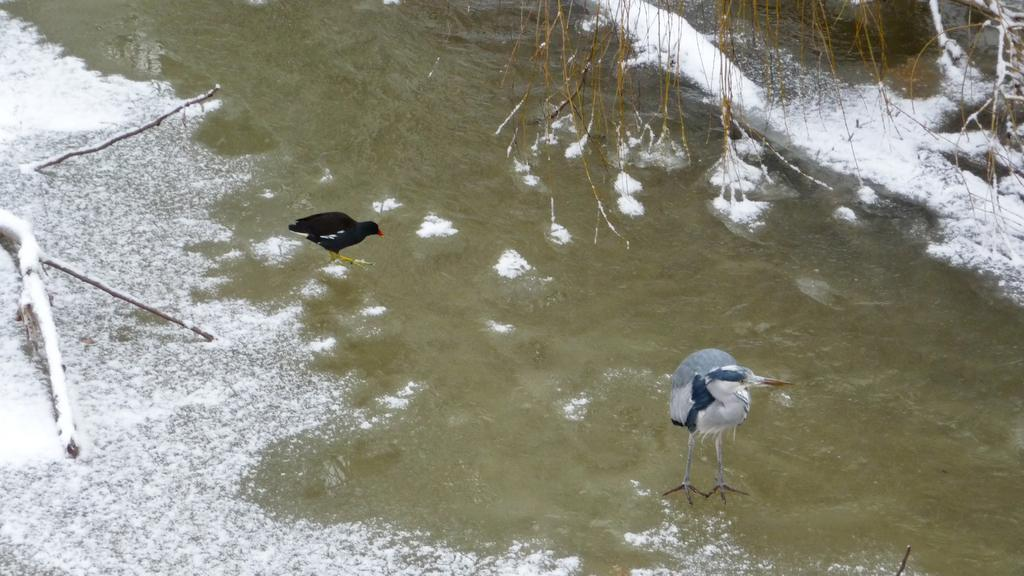What animals can be seen in the image? There is a hen and a duck in the image. Where is the duck located in the image? The duck is on the water in the image. What type of vegetation is present in the image? There are dried branches in the image. What is the weather like in the image? There is snow in the image, indicating a cold environment. What type of berry can be seen in the image? There is no berry present in the image. What advice does the father give to the duck in the image? There is no father or conversation depicted in the image, so it is not possible to answer that question. 